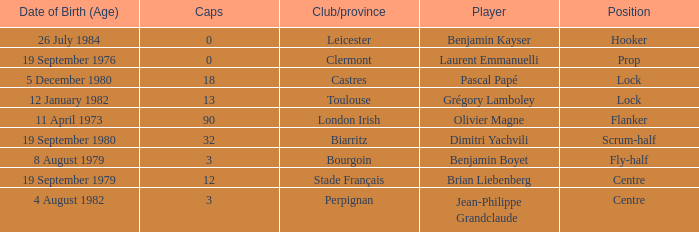What is the birthday of caps of 32? 19 September 1980. 